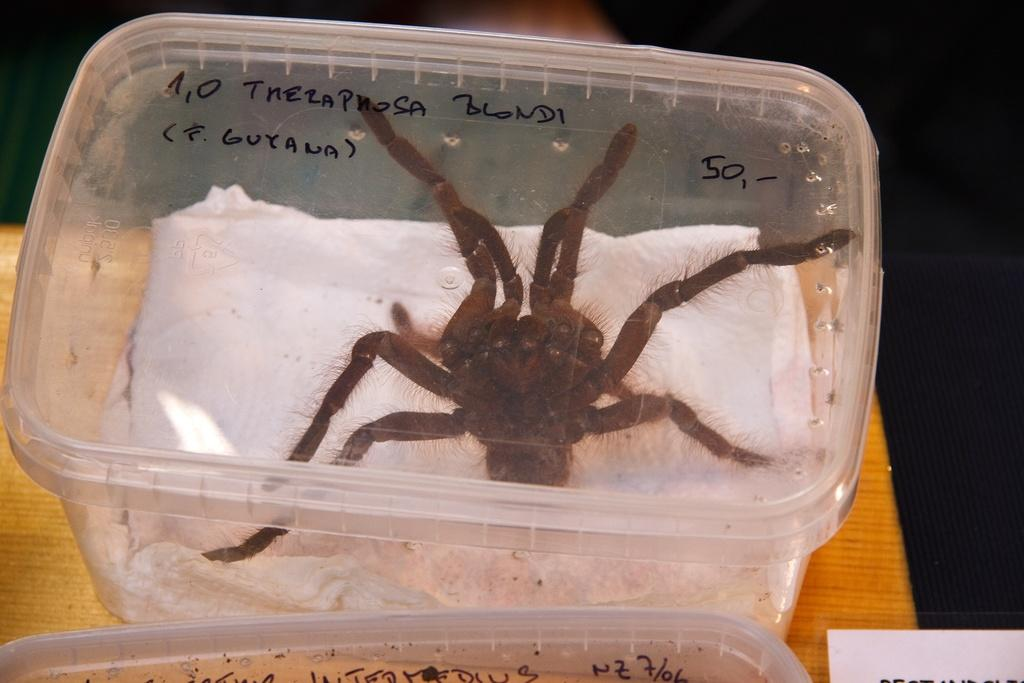What is inside the box in the image? There is a spider in a box in the image. What else can be seen in the image? There is another box at the bottom of the image on a table. What is written or printed on the boxes? There is text on the boxes. What type of pipe is visible in the image? There is no pipe present in the image. Can you tell me how many cups are on the table in the image? There is no cup present in the image. 